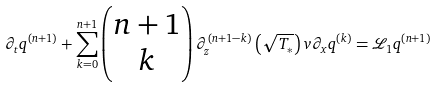Convert formula to latex. <formula><loc_0><loc_0><loc_500><loc_500>\partial _ { t } q ^ { ( n + 1 ) } + \sum _ { k = 0 } ^ { n + 1 } \begin{pmatrix} n + 1 \\ k \end{pmatrix} \partial _ { z } ^ { ( n + 1 - k ) } \left ( \sqrt { T _ { \ast } } \right ) v \partial _ { x } q ^ { ( k ) } = \mathcal { L } _ { 1 } q ^ { ( n + 1 ) }</formula> 